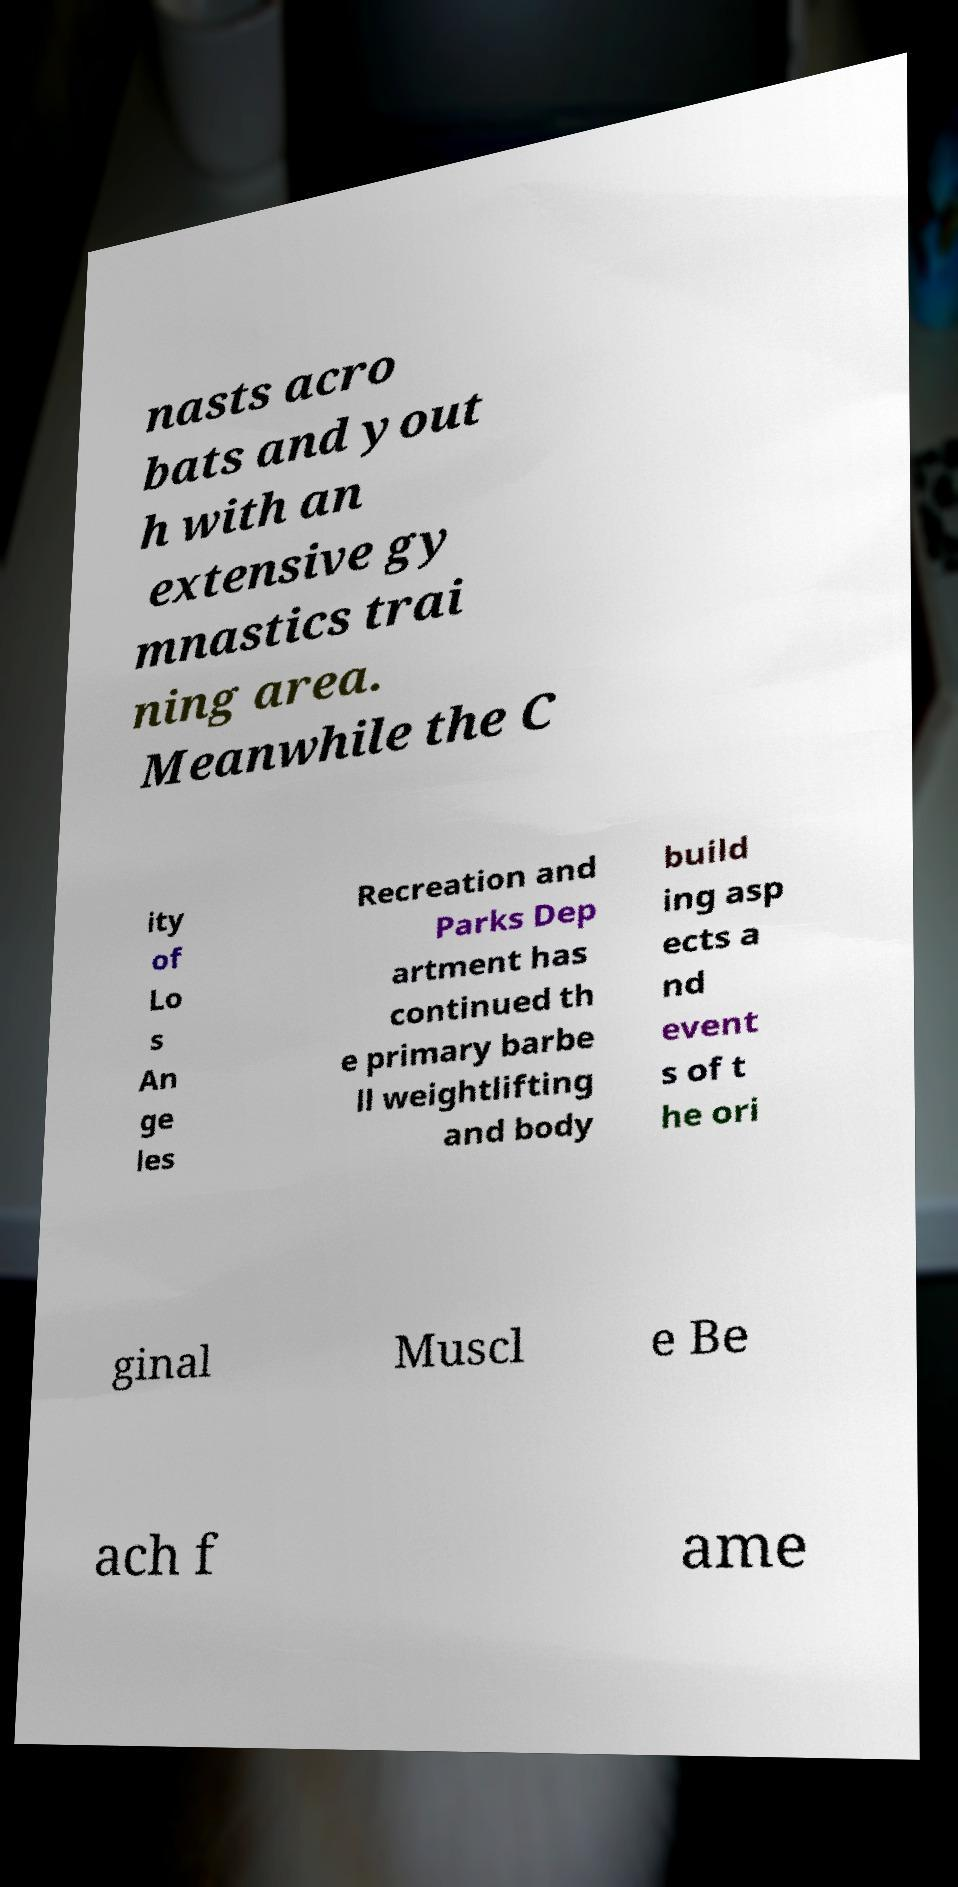Can you read and provide the text displayed in the image?This photo seems to have some interesting text. Can you extract and type it out for me? nasts acro bats and yout h with an extensive gy mnastics trai ning area. Meanwhile the C ity of Lo s An ge les Recreation and Parks Dep artment has continued th e primary barbe ll weightlifting and body build ing asp ects a nd event s of t he ori ginal Muscl e Be ach f ame 